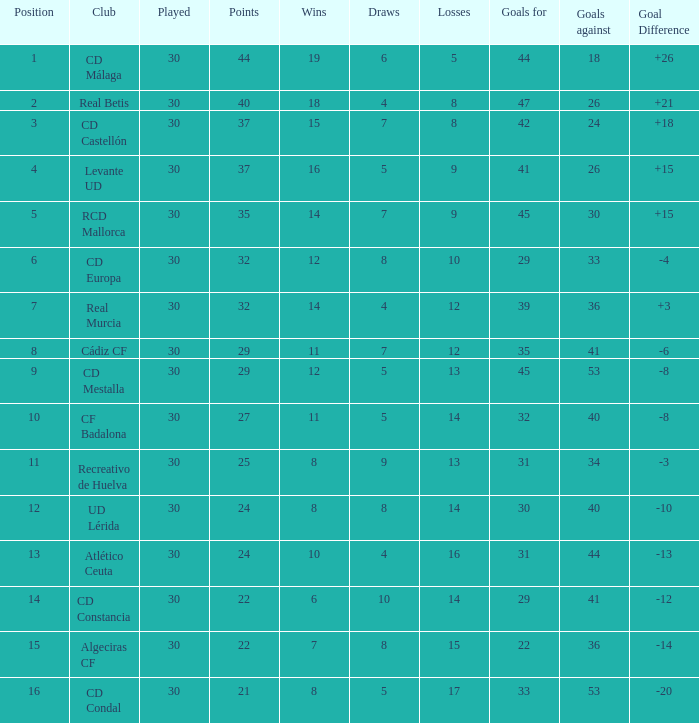What is the number of wins when the points were less than 27 and the goals against were 41? 6.0. 